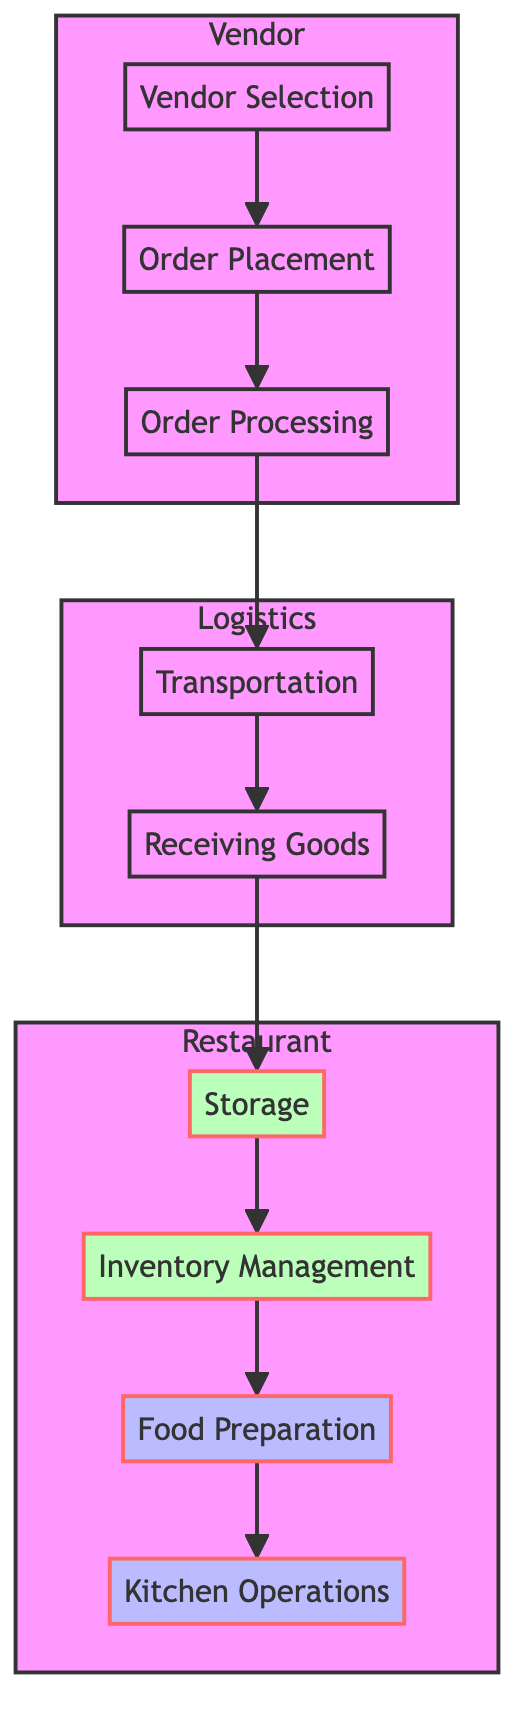What is the first step in the supply chain? The first step in the flowchart is "Vendor Selection," which is where reliable suppliers for fresh produce and ingredients are chosen.
Answer: Vendor Selection How many primary nodes are present in the diagram? There are nine primary nodes, each representing a different step in the supply chain management process from vendor selection to kitchen operations.
Answer: Nine What connects "Order Placement" to "Order Processing"? The connection between "Order Placement" and "Order Processing" is a direct flow indicating that after an order is placed, it moves to the processing stage.
Answer: Direct flow What type of storage is mentioned in the diagram? The diagram specifies "Cold Storage" and "Dry Storage" as types of storage used for food ingredients in the restaurant.
Answer: Cold Storage and Dry Storage Which subgraph contains "Transportation"? The subgraph that contains "Transportation" is labeled "Logistics," which focuses on the movement of goods from vendors to the restaurant.
Answer: Logistics What happens after "Receiving Goods"? After "Receiving Goods," the next step in the flow is "Storage," indicating that the received items are properly stored in the restaurant.
Answer: Storage How many processes are involved in "Kitchen Operations"? There are two main processes involved in "Kitchen Operations," which are "Cooking" and "Plating," transforming ingredients into menu items.
Answer: Two Which step is last in the sequence? The last step in the sequence is "Kitchen Operations," where all the prepared ingredients are cooked and plated for service.
Answer: Kitchen Operations What describes the entities in the "Order Processing" step? The entities in the "Order Processing" step include "Order Confirmation" and "Inventory Update," reflecting what occurs during order processing.
Answer: Order Confirmation and Inventory Update 